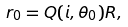Convert formula to latex. <formula><loc_0><loc_0><loc_500><loc_500>r _ { 0 } = Q ( i , \theta _ { 0 } ) R ,</formula> 